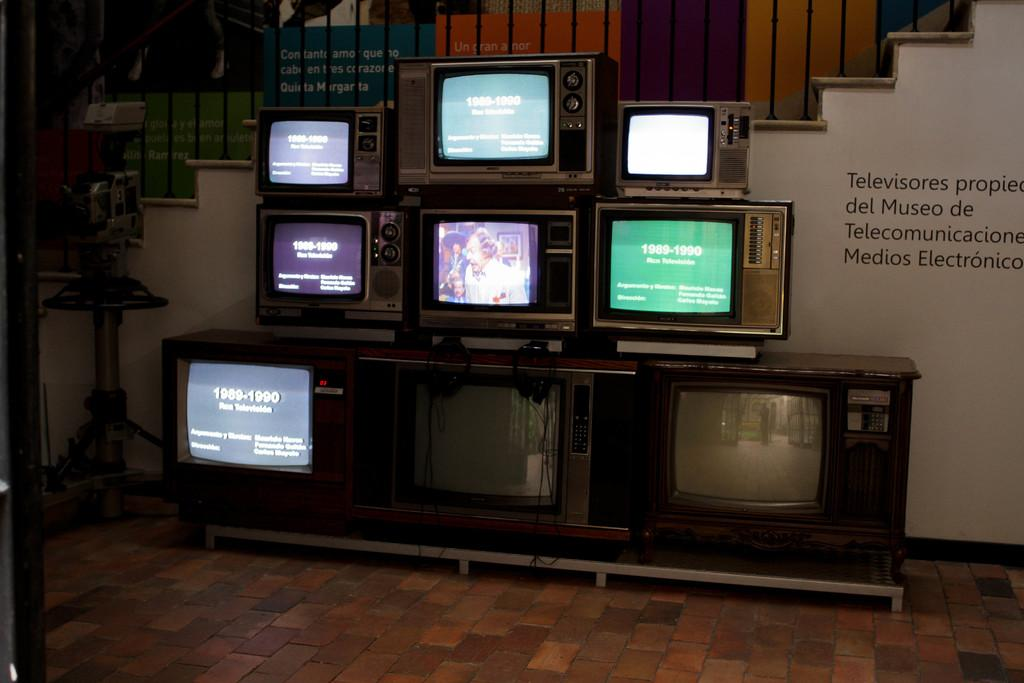What is the main subject of the image? The main subject of the image is televisions. Where are the televisions located? The televisions are placed on a table. What is the table resting on? The table is on the floor. What can be seen in the background of the image? There are stairs and a wall visible in the background of the image. Can you see any fairies flying around the televisions in the image? No, there are no fairies present in the image. Are there any tomatoes growing on the wall in the background? No, there are no tomatoes visible in the image. 